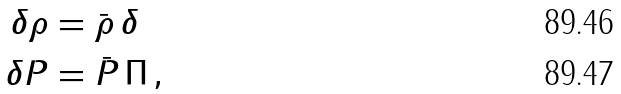<formula> <loc_0><loc_0><loc_500><loc_500>\delta \rho & = \bar { \rho } \, \delta \\ \delta P & = \bar { P } \, \Pi \, ,</formula> 